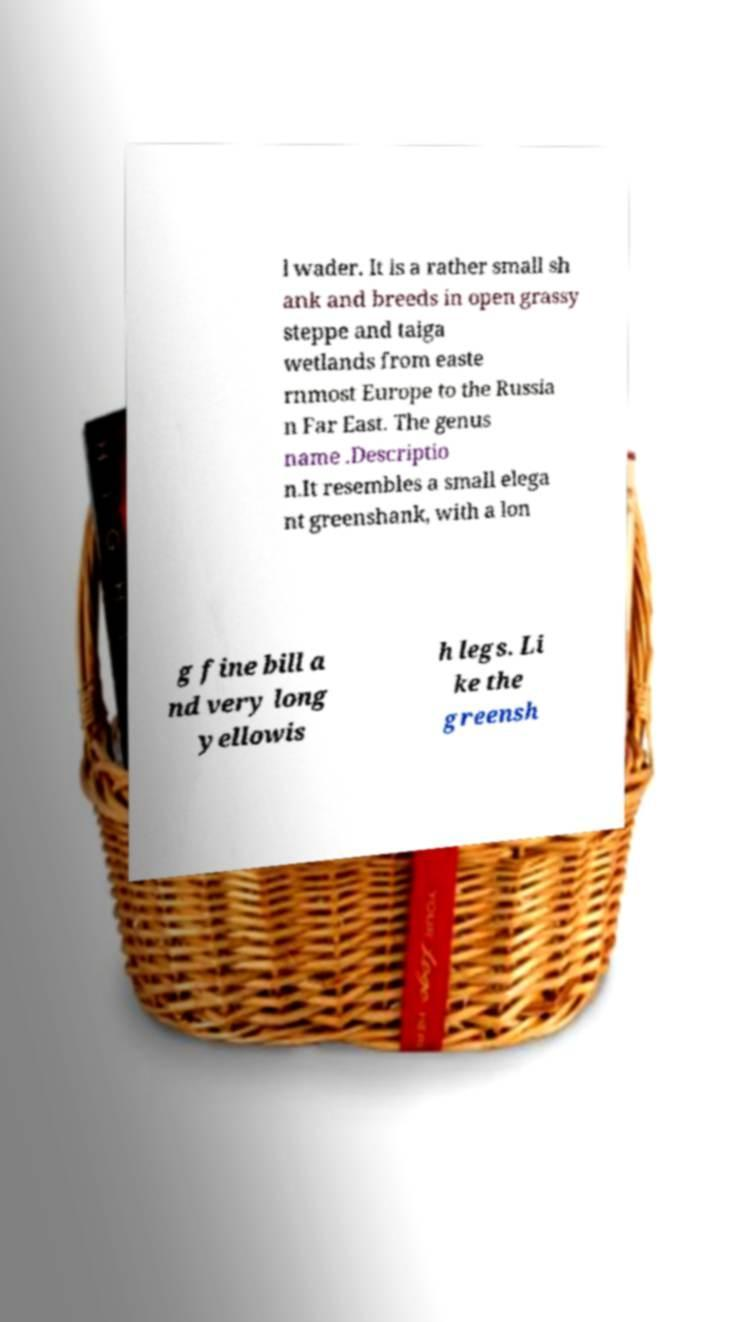Can you read and provide the text displayed in the image?This photo seems to have some interesting text. Can you extract and type it out for me? l wader. It is a rather small sh ank and breeds in open grassy steppe and taiga wetlands from easte rnmost Europe to the Russia n Far East. The genus name .Descriptio n.It resembles a small elega nt greenshank, with a lon g fine bill a nd very long yellowis h legs. Li ke the greensh 